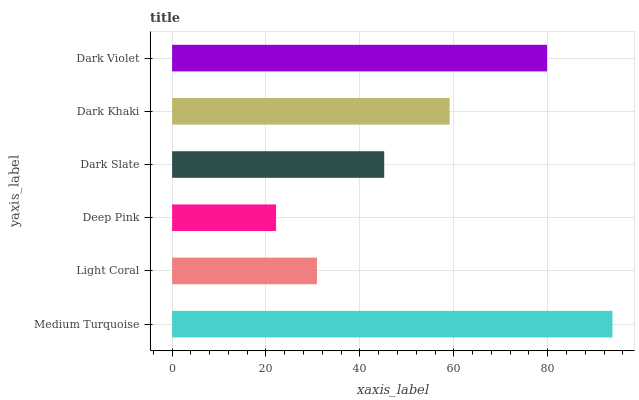Is Deep Pink the minimum?
Answer yes or no. Yes. Is Medium Turquoise the maximum?
Answer yes or no. Yes. Is Light Coral the minimum?
Answer yes or no. No. Is Light Coral the maximum?
Answer yes or no. No. Is Medium Turquoise greater than Light Coral?
Answer yes or no. Yes. Is Light Coral less than Medium Turquoise?
Answer yes or no. Yes. Is Light Coral greater than Medium Turquoise?
Answer yes or no. No. Is Medium Turquoise less than Light Coral?
Answer yes or no. No. Is Dark Khaki the high median?
Answer yes or no. Yes. Is Dark Slate the low median?
Answer yes or no. Yes. Is Dark Violet the high median?
Answer yes or no. No. Is Deep Pink the low median?
Answer yes or no. No. 